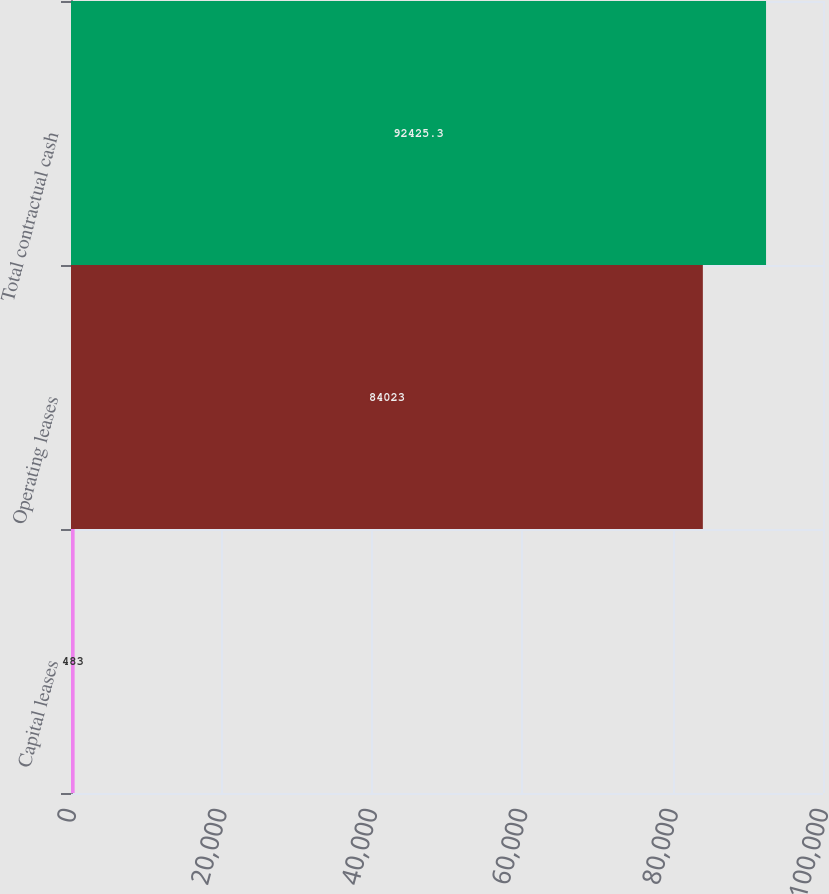Convert chart. <chart><loc_0><loc_0><loc_500><loc_500><bar_chart><fcel>Capital leases<fcel>Operating leases<fcel>Total contractual cash<nl><fcel>483<fcel>84023<fcel>92425.3<nl></chart> 